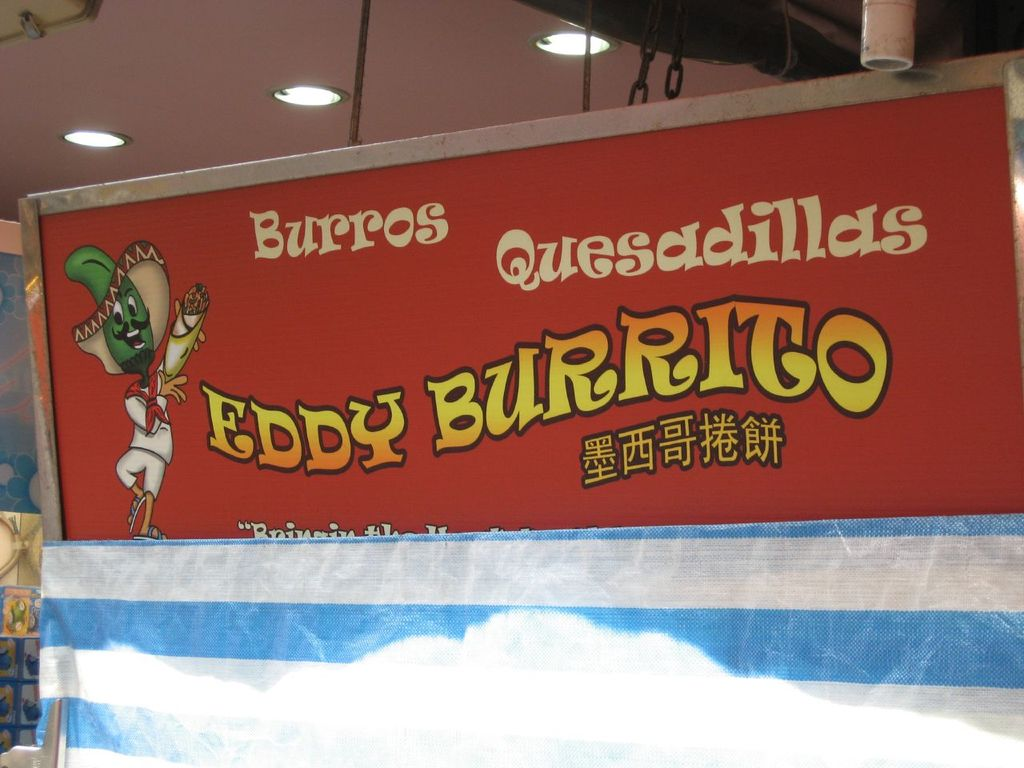What do you think is going on in this snapshot? The image showcases a vibrant sign for a Mexican restaurant named "Eddy Burrito". The sign, painted in a striking red with yellow text, prominently features a playful cartoon character of a green lizard. The lizard, donning a sombrero and holding a burrito, adds a touch of whimsy to the restaurant's branding. The sign also highlights the key offerings of the restaurant - burritos and quesadillas, indicating the type of cuisine patrons can expect. An additional line of text on the sign reads "Bringing the taste of Mexico to Hong Kong", suggesting the restaurant's mission to introduce Mexican flavors to the local food scene. The sign is affixed to a building with a blue awning, further adding to the colorful and inviting exterior of the restaurant. 